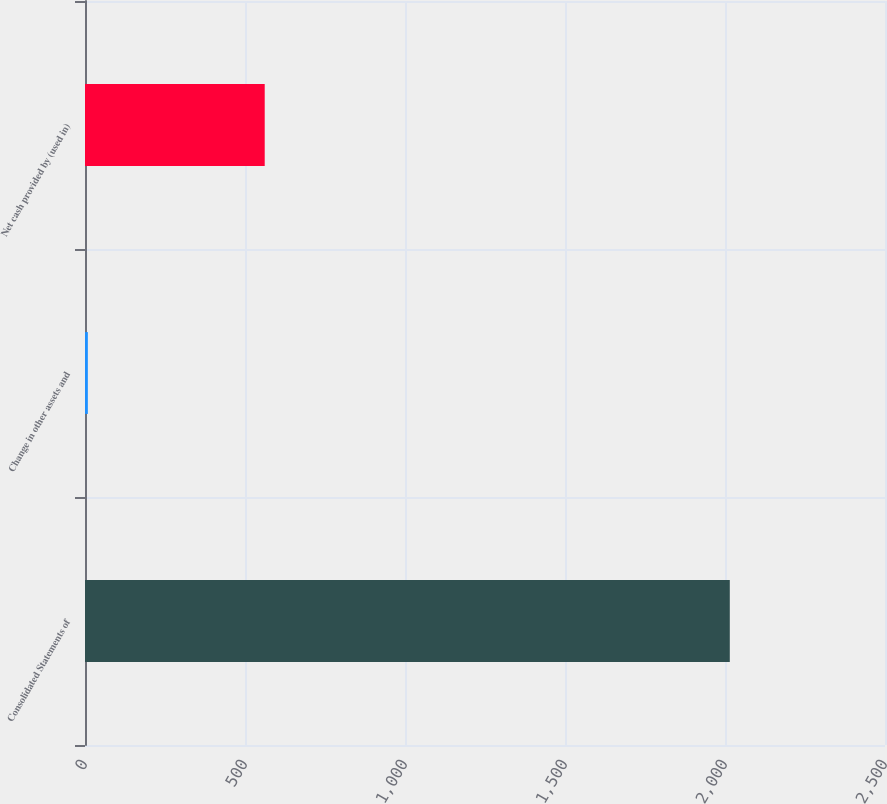Convert chart. <chart><loc_0><loc_0><loc_500><loc_500><bar_chart><fcel>Consolidated Statements of<fcel>Change in other assets and<fcel>Net cash provided by (used in)<nl><fcel>2015<fcel>8.9<fcel>561.6<nl></chart> 